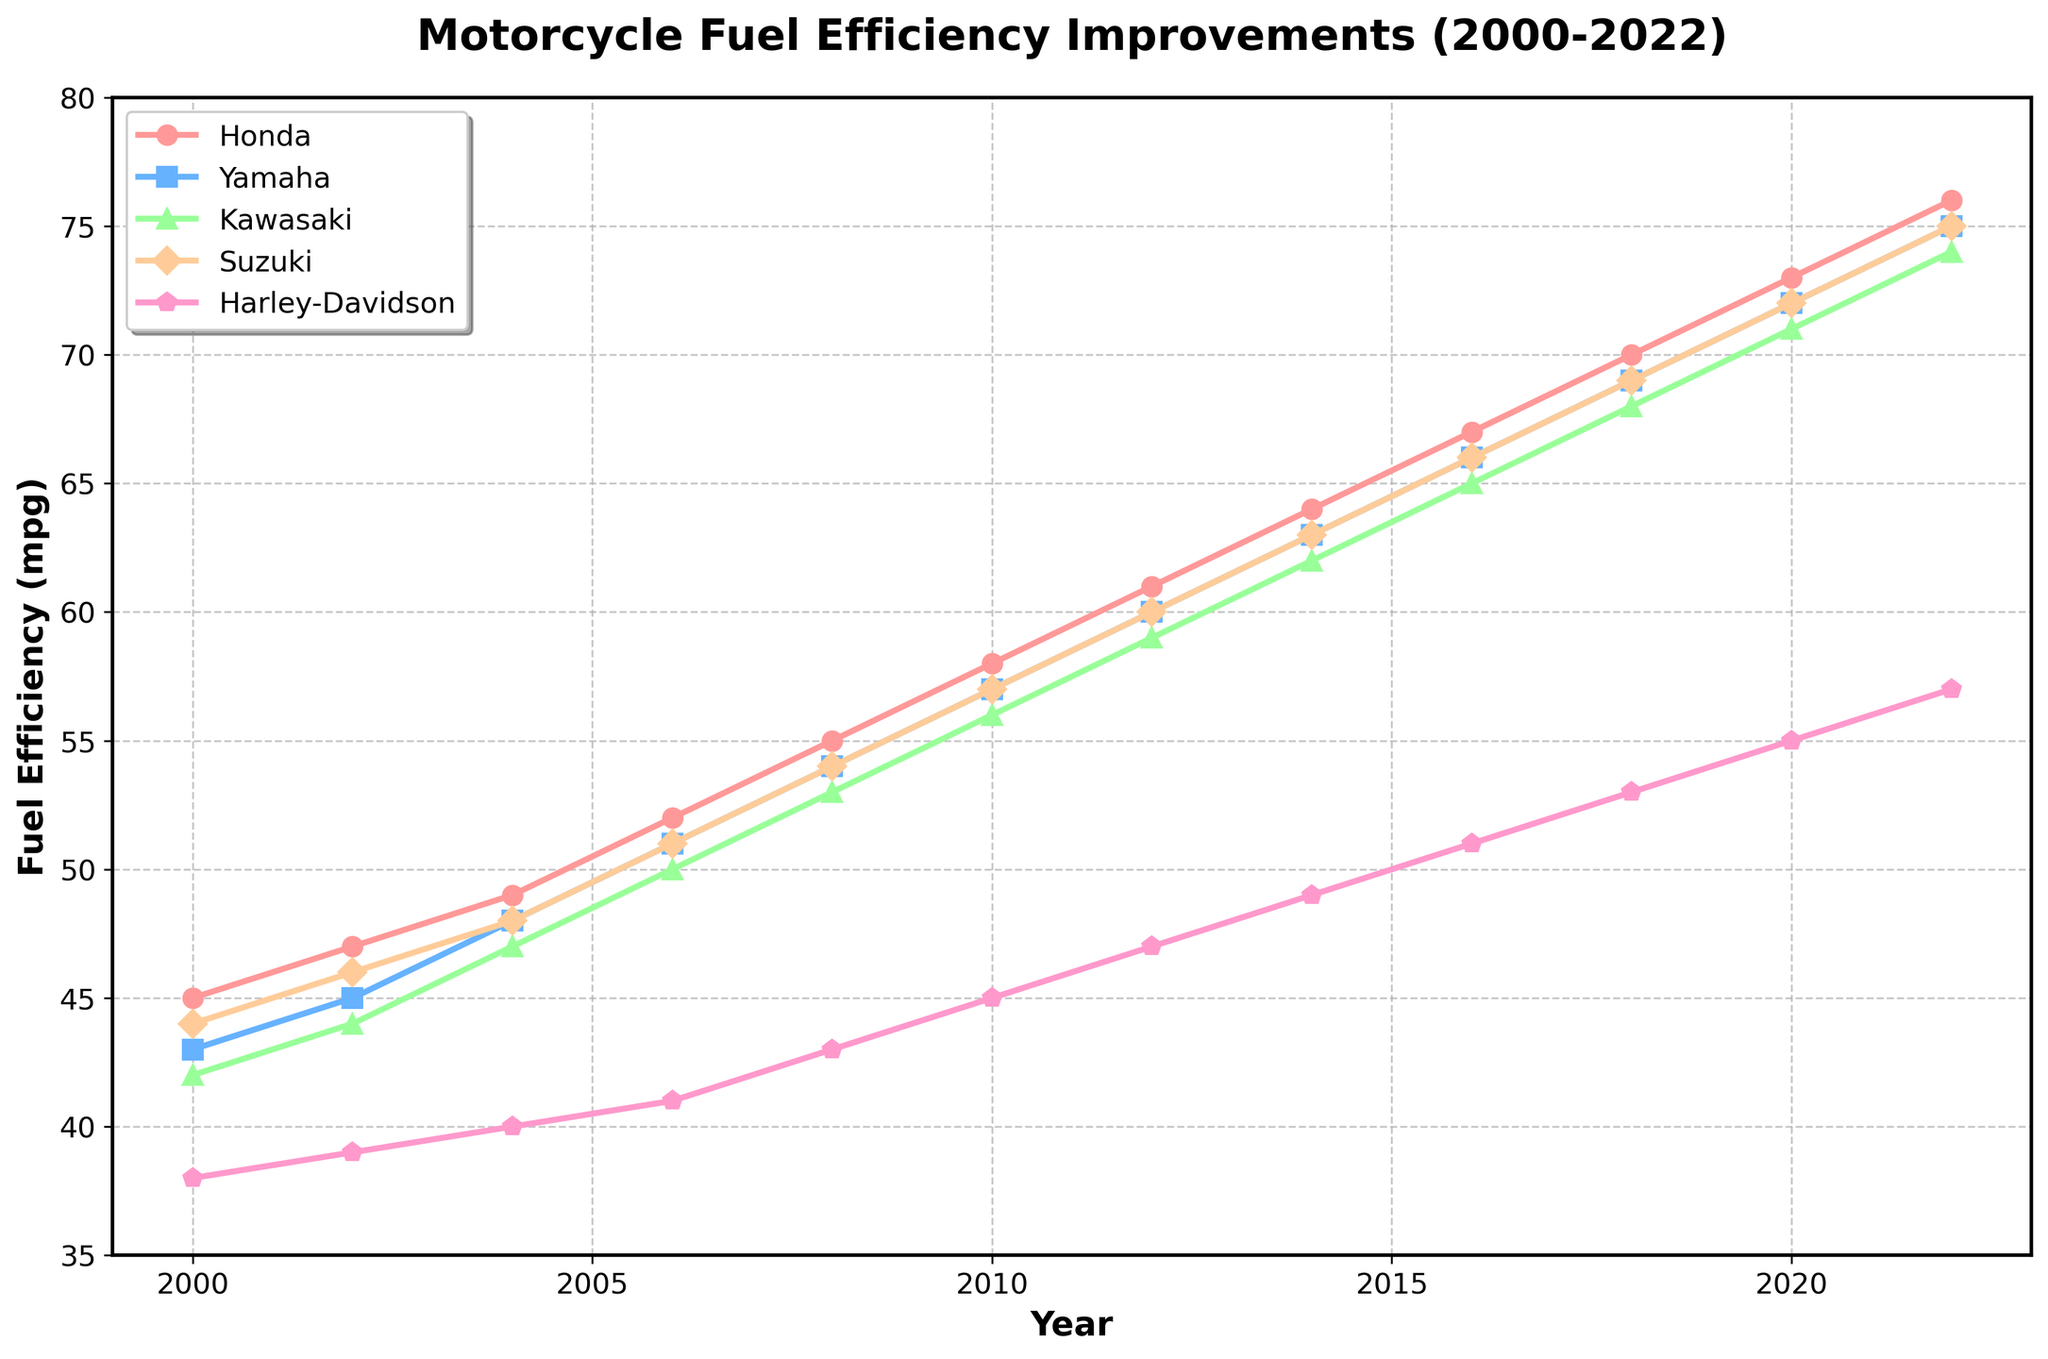How does Honda's fuel efficiency in 2022 compare to its fuel efficiency in 2000? To find this, we look at the y-axis values for Honda in 2022 and 2000 on the line chart. In 2022, Honda's fuel efficiency is 76 mpg, and in 2000, it is 45 mpg.
Answer: Honda's fuel efficiency improved by 31 mpg from 2000 to 2022 Which manufacturer showed the least improvement in fuel efficiency from 2000 to 2022? We need to calculate the difference in fuel efficiency between 2000 and 2022 for each manufacturer by subtracting the 2000 value from the 2022 value. Harley-Davidson's improvement is the smallest: 57 - 38 = 19 mpg.
Answer: Harley-Davidson What is the overall trend for fuel efficiency for all manufacturers from 2000 to 2022? Observing the upward-sloping lines for each manufacturer indicates an overall improving trend in fuel efficiency over this period.
Answer: Increasing Comparing Yamaha and Kawasaki, which had better fuel efficiency in 2016? Looking at the values in 2016, Yamaha's efficiency is 66 mpg and Kawasaki's is 65 mpg. Therefore, Yamaha had slightly better fuel efficiency.
Answer: Yamaha By how many mpg did Suzuki's fuel efficiency improve between 2010 and 2018? To determine the improvement, subtract the fuel efficiency in 2010 from that in 2018 for Suzuki: 69 - 57 = 12 mpg.
Answer: 12 mpg In which year did Harley-Davidson's fuel efficiency reach 45 mpg? Locate the point on the Harley-Davidson line where y = 45 mpg. This occurs in the year 2010.
Answer: 2010 What is the average fuel efficiency of Honda between 2000 and 2020? Sum the fuel efficiency values for Honda from 2000 to 2020 and divide by the number of years: (45 + 47 + 49 + 52 + 55 + 58 + 61 + 64 + 67 + 70 + 73) / 11 = 56.36 mpg.
Answer: 56.36 mpg Which manufacturer's line is represented in blue? Observing the colors of the lines, Yamaha's line is represented in blue.
Answer: Yamaha Find the trend in fuel efficiency for Kawasaki between 2006 and 2010. Observe the slope of Kawasaki's line segment from 2006 to 2010. The line is upward sloping, indicating an increase in fuel efficiency from 50 mpg to 56 mpg.
Answer: Increasing 